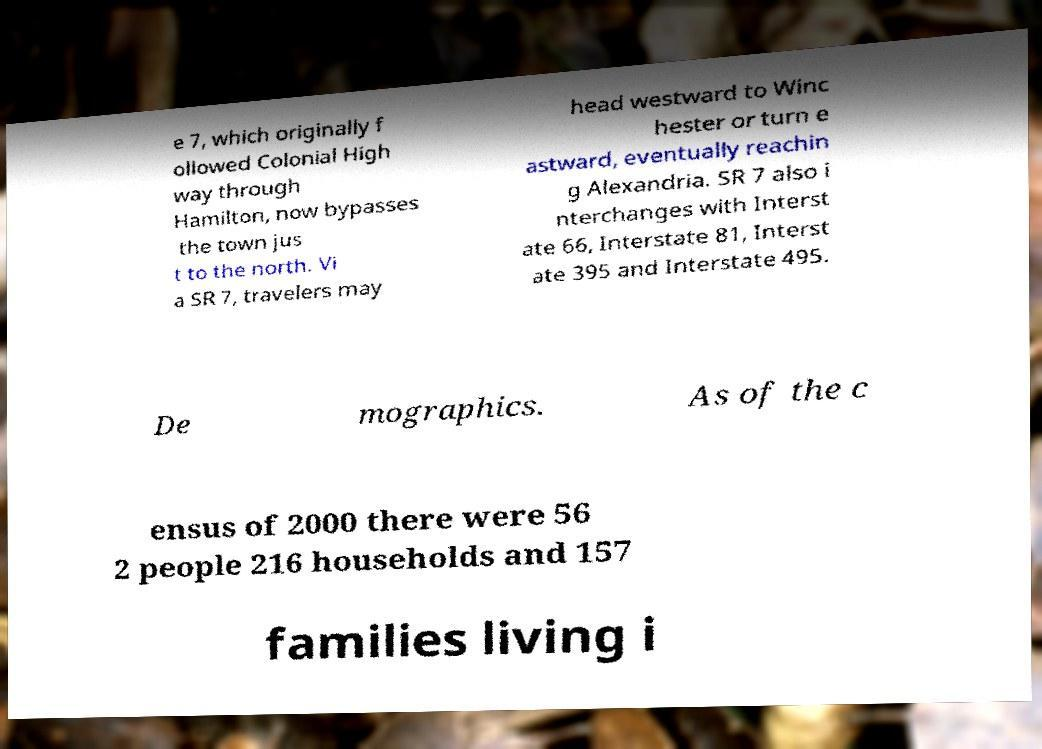What messages or text are displayed in this image? I need them in a readable, typed format. e 7, which originally f ollowed Colonial High way through Hamilton, now bypasses the town jus t to the north. Vi a SR 7, travelers may head westward to Winc hester or turn e astward, eventually reachin g Alexandria. SR 7 also i nterchanges with Interst ate 66, Interstate 81, Interst ate 395 and Interstate 495. De mographics. As of the c ensus of 2000 there were 56 2 people 216 households and 157 families living i 